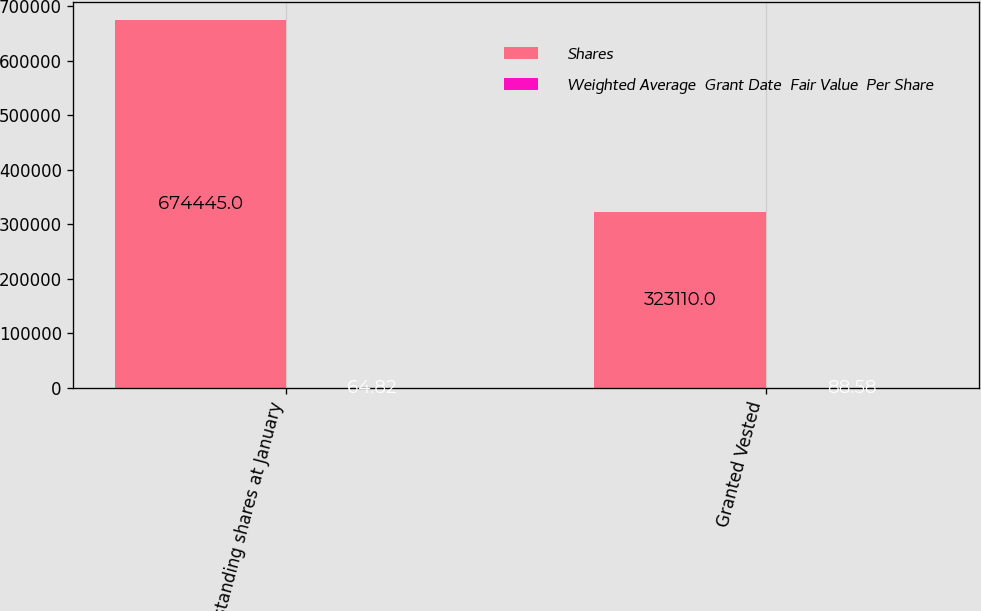Convert chart to OTSL. <chart><loc_0><loc_0><loc_500><loc_500><stacked_bar_chart><ecel><fcel>Outstanding shares at January<fcel>Granted Vested<nl><fcel>Shares<fcel>674445<fcel>323110<nl><fcel>Weighted Average  Grant Date  Fair Value  Per Share<fcel>64.82<fcel>88.58<nl></chart> 